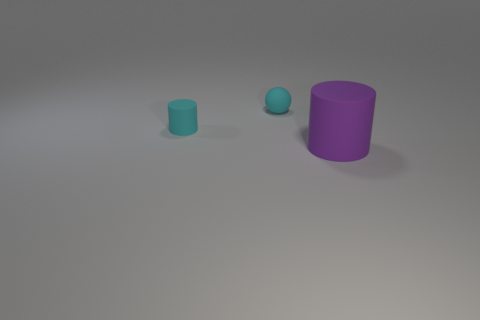Add 2 cylinders. How many objects exist? 5 Add 3 matte cylinders. How many matte cylinders exist? 5 Subtract 0 yellow cubes. How many objects are left? 3 Subtract all cylinders. How many objects are left? 1 Subtract 1 cylinders. How many cylinders are left? 1 Subtract all purple cylinders. Subtract all purple balls. How many cylinders are left? 1 Subtract all gray spheres. How many cyan cylinders are left? 1 Subtract all tiny purple rubber blocks. Subtract all large matte things. How many objects are left? 2 Add 2 cylinders. How many cylinders are left? 4 